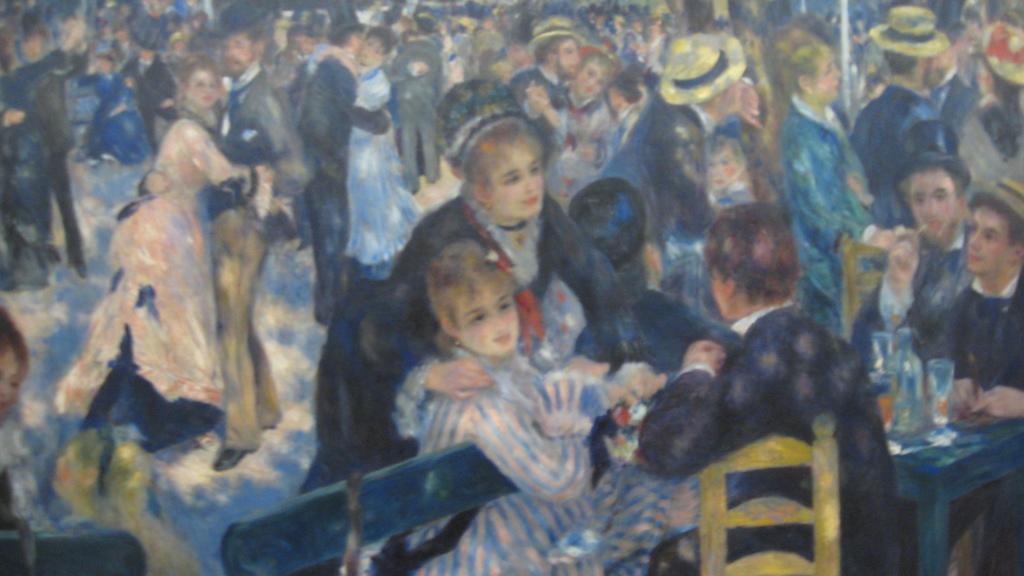Please provide a concise description of this image. Here we can see a painting, in this painting we can see some people dancing, on the right side there are some people sitting on chairs in front of a table, some of these people wore caps. 